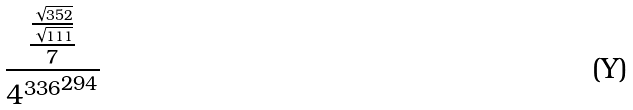<formula> <loc_0><loc_0><loc_500><loc_500>\frac { \frac { \frac { \sqrt { 3 5 2 } } { \sqrt { 1 1 1 } } } { 7 } } { { 4 ^ { 3 3 6 } } ^ { 2 9 4 } }</formula> 